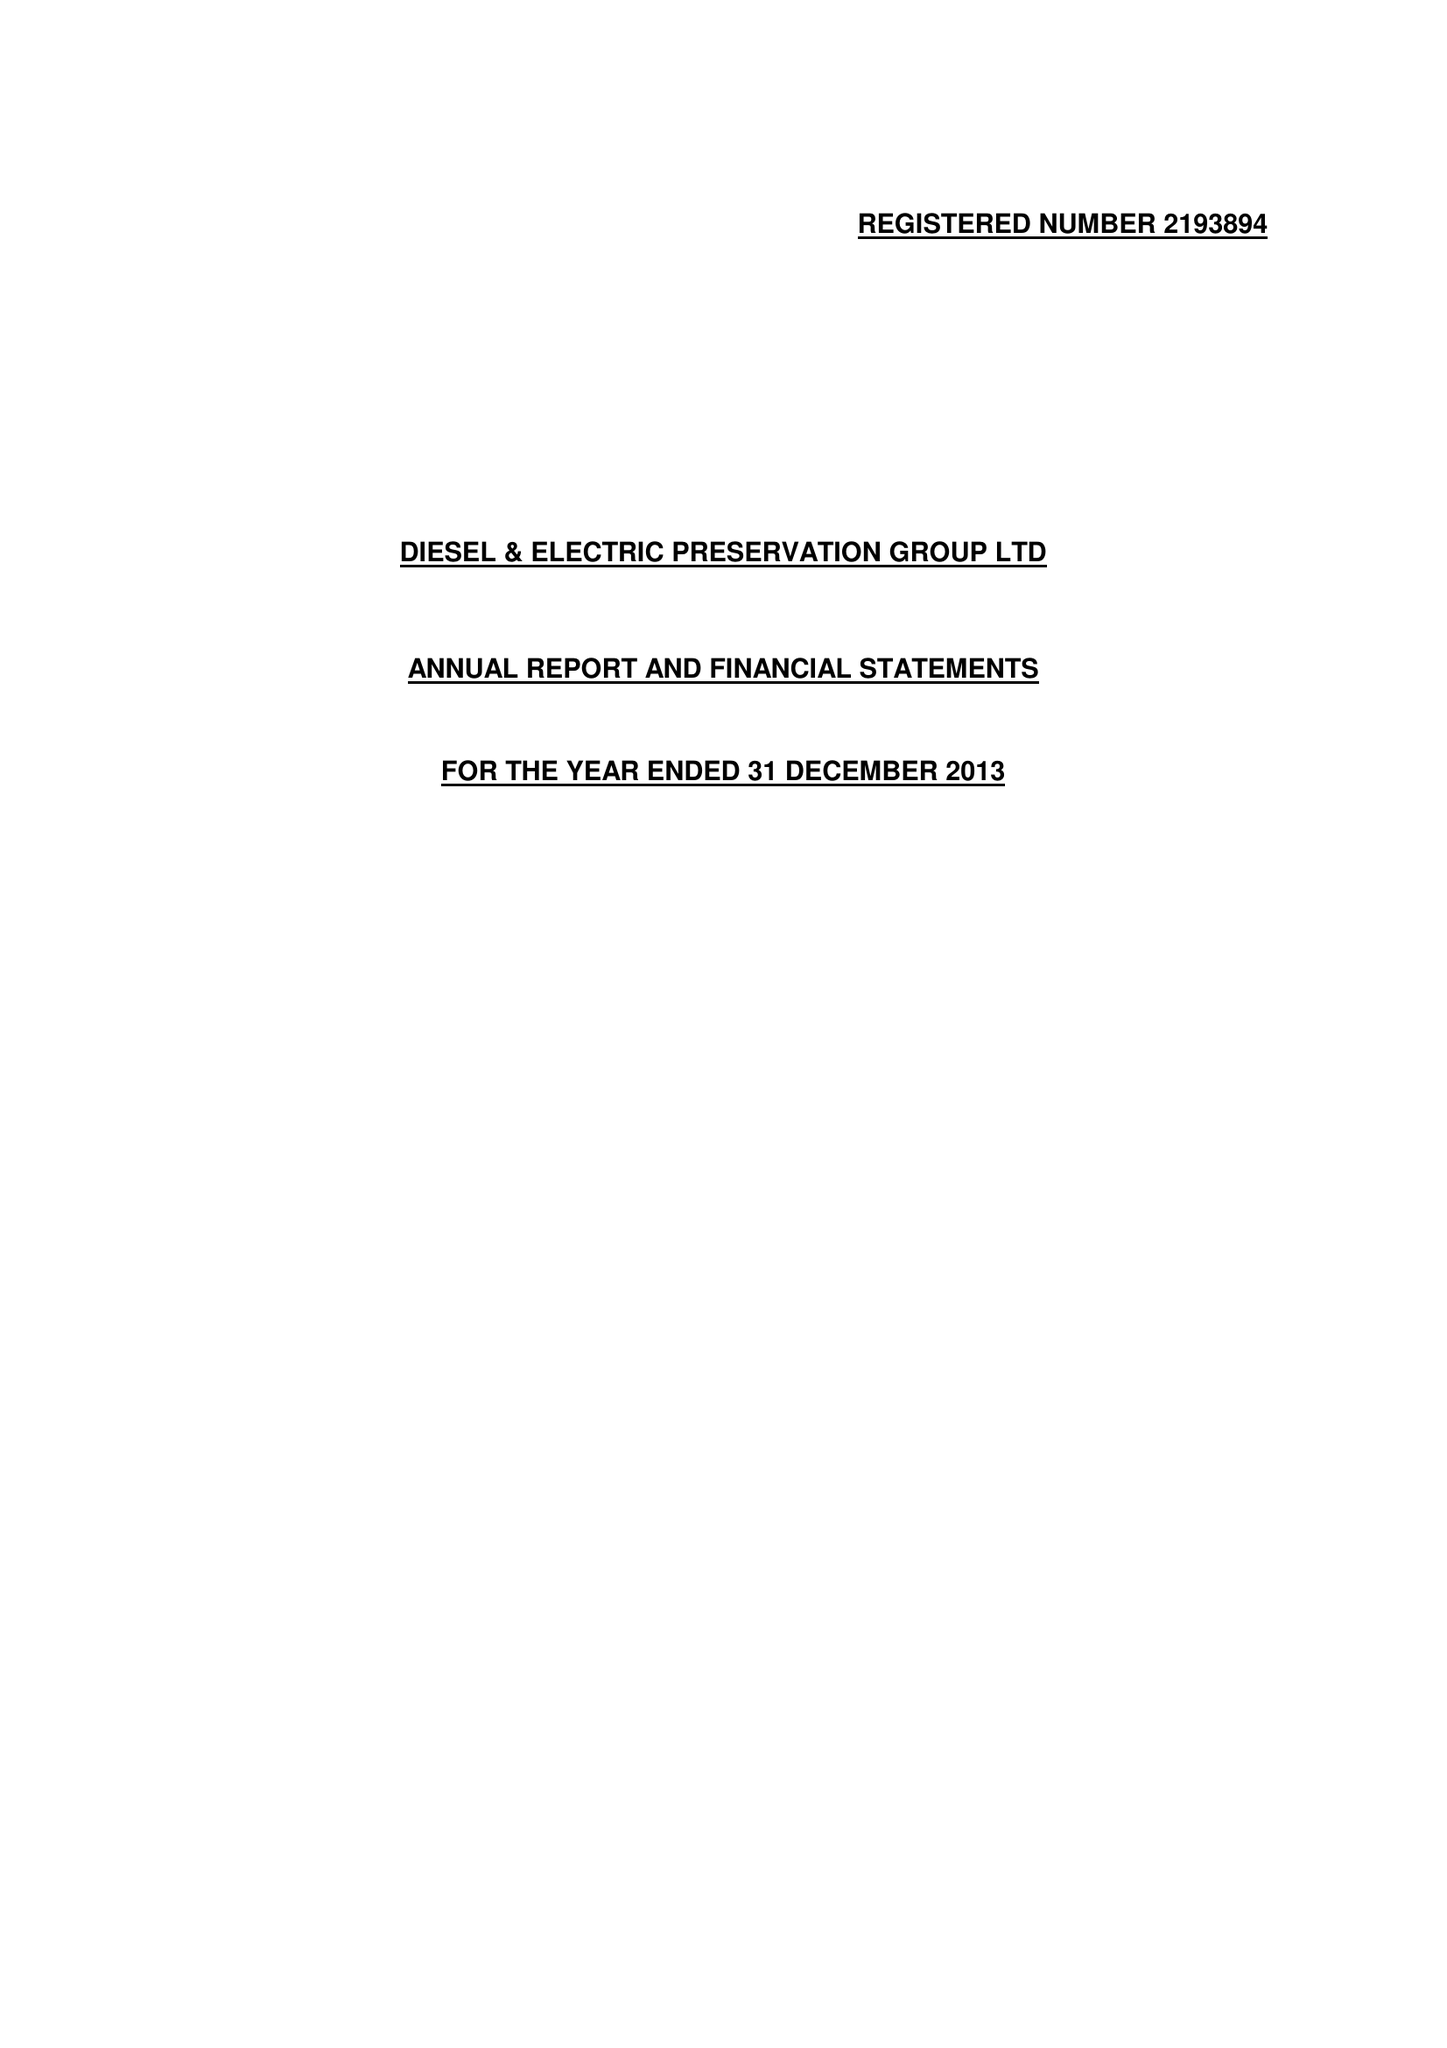What is the value for the charity_number?
Answer the question using a single word or phrase. 298142 